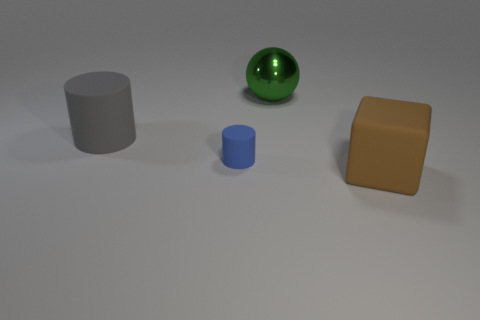Add 2 green objects. How many objects exist? 6 Subtract all spheres. How many objects are left? 3 Subtract 1 blue cylinders. How many objects are left? 3 Subtract all big brown matte cubes. Subtract all small blue things. How many objects are left? 2 Add 4 gray rubber cylinders. How many gray rubber cylinders are left? 5 Add 1 large red things. How many large red things exist? 1 